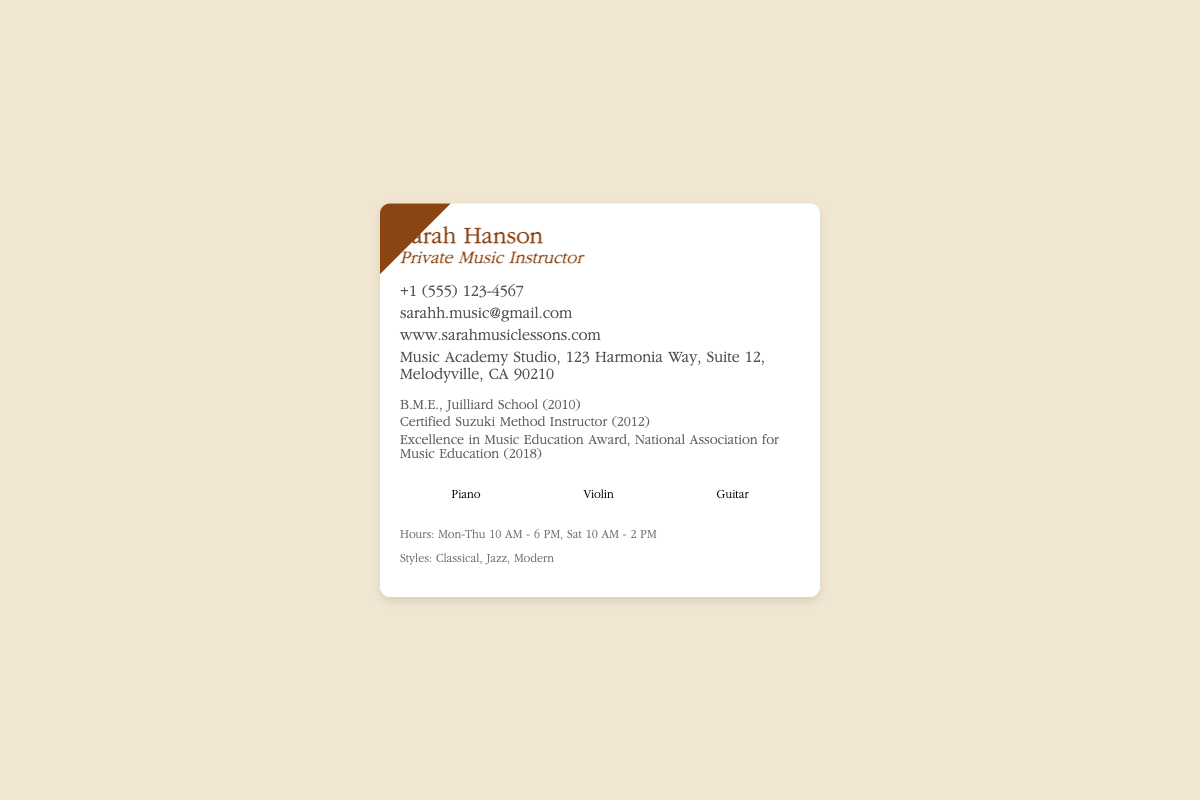what is the name of the instructor? The instructor's name is listed at the top of the business card.
Answer: Sarah Hanson what is the email address provided? The email address is included in the contact information section.
Answer: sarahh.music@gmail.com what degree does Sarah hold? The degree is mentioned in the credentials section of the card.
Answer: B.M.E., Juilliard School (2010) how many instruments are listed on the card? The card provides a specific number of instruments in the instruments section.
Answer: Three what awards has Sarah received? The credentials section mentions specific awards in music education.
Answer: Excellence in Music Education Award when are the teaching hours? The business card includes the specific days and times Sarah is available for lessons.
Answer: Mon-Thu 10 AM - 6 PM, Sat 10 AM - 2 PM which teaching method is certified? The credentials section indicates a specific teaching method that Sarah is certified in.
Answer: Suzuki Method what genre does Sarah teach? The hours section of the card mentions the styles of music taught by Sarah.
Answer: Classical, Jazz, Modern where is Sarah's studio located? The location of the studio is provided in the contact information section.
Answer: Music Academy Studio, 123 Harmonia Way, Suite 12, Melodyville, CA 90210 